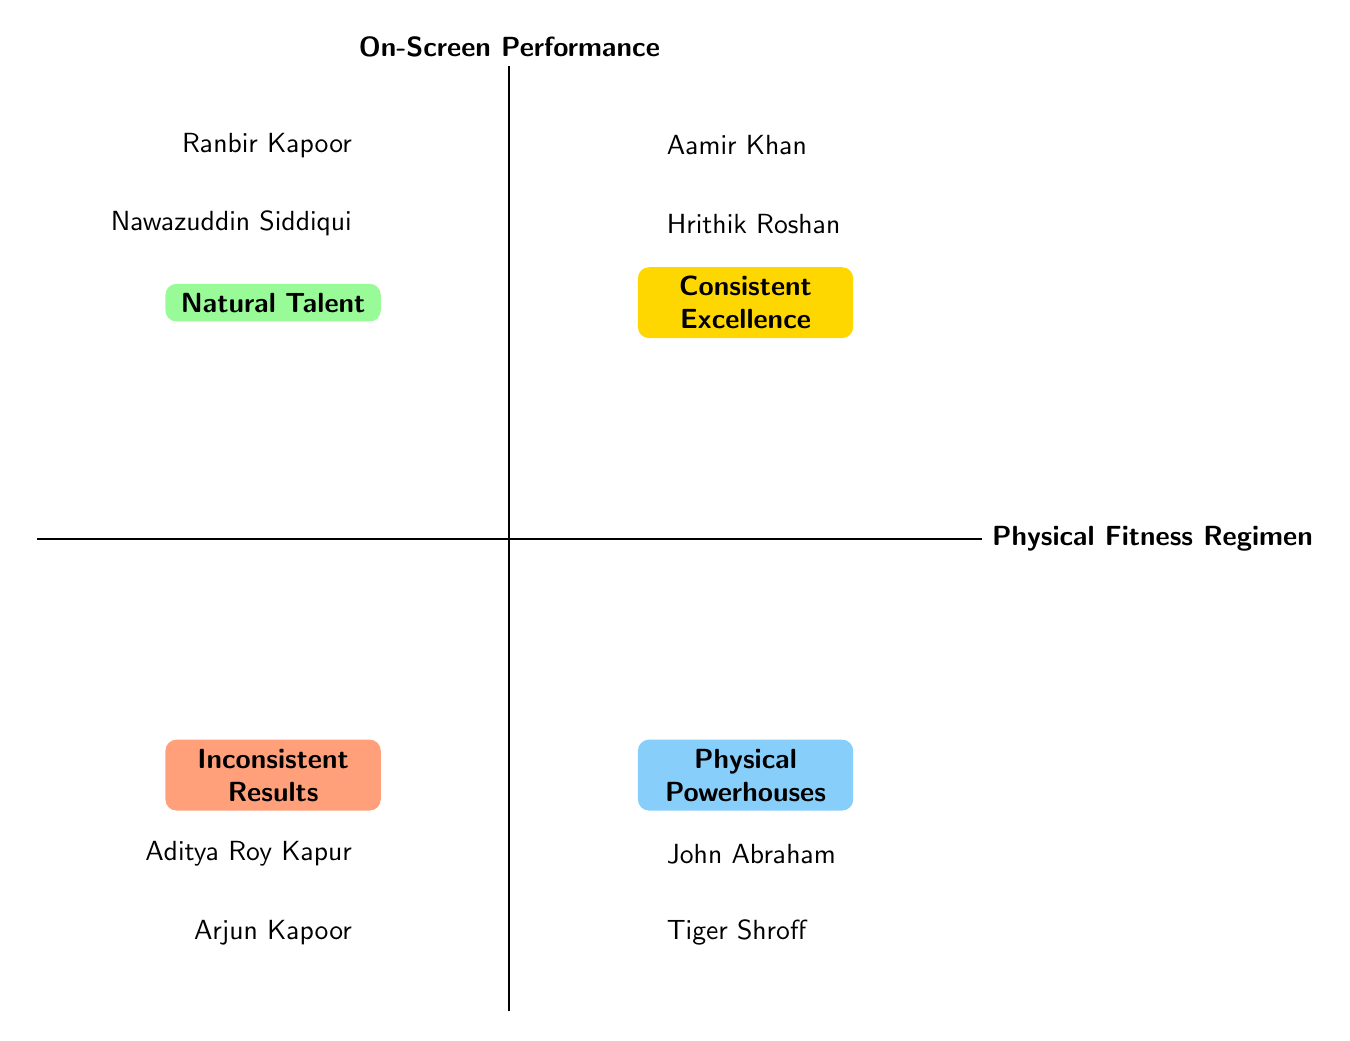What is the title of the top-left quadrant? The top-left quadrant is labeled "Natural Talent," which indicates that it features elements characterized by inherent abilities rather than rigorous fitness regimes.
Answer: Natural Talent How many actors are listed in the bottom-right quadrant? The bottom-right quadrant, titled "Physical Powerhouses," contains two actors: Tiger Shroff and John Abraham, showcasing those with strong physical fitness.
Answer: 2 Which actor is in the "Consistent Excellence" quadrant? The actors in the "Consistent Excellence" quadrant include Aamir Khan and Hrithik Roshan. Focusing on Aamir Khan illustrates how his fitness regimen supports strong performances.
Answer: Aamir Khan What performance category does Arjun Kapoor fall into? Arjun Kapoor is placed in the bottom-left quadrant, labeled "Inconsistent Results," indicating that he may struggle with consistent on-screen impact due to varying fitness levels.
Answer: Inconsistent Results Who demonstrates a high-intensity workout approach leading to versatile performances? Hrithik Roshan is recognized for his high-intensity workouts that enhance his performance versatility, placing him in the top-right quadrant of consistent excellence.
Answer: Hrithik Roshan Which two actors are associated with method acting and minimal fitness regimens? Ranbir Kapoor and Nawazuddin Siddiqui are both featured in the top-left quadrant as they rely more on their inherent talent and acting methods than on physical fitness.
Answer: Ranbir Kapoor, Nawazuddin Siddiqui What is the title of the quadrant that includes Tiger Shroff? The quadrant featuring Tiger Shroff is titled "Physical Powerhouses," emphasizing actors whose fitness directly enhances their performance capabilities, particularly in action roles.
Answer: Physical Powerhouses Which quadrant contains actors with fluctuating dedication to fitness? The quadrant that includes actors with fluctuating dedication to fitness is titled "Inconsistent Results," where both Arjun Kapoor and Aditya Roy Kapur are placed.
Answer: Inconsistent Results 